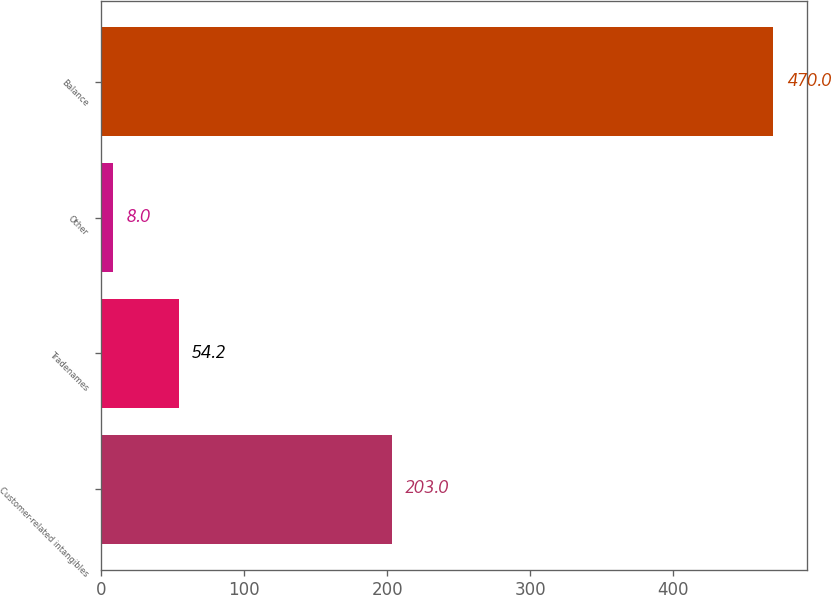<chart> <loc_0><loc_0><loc_500><loc_500><bar_chart><fcel>Customer-related intangibles<fcel>Tradenames<fcel>Other<fcel>Balance<nl><fcel>203<fcel>54.2<fcel>8<fcel>470<nl></chart> 